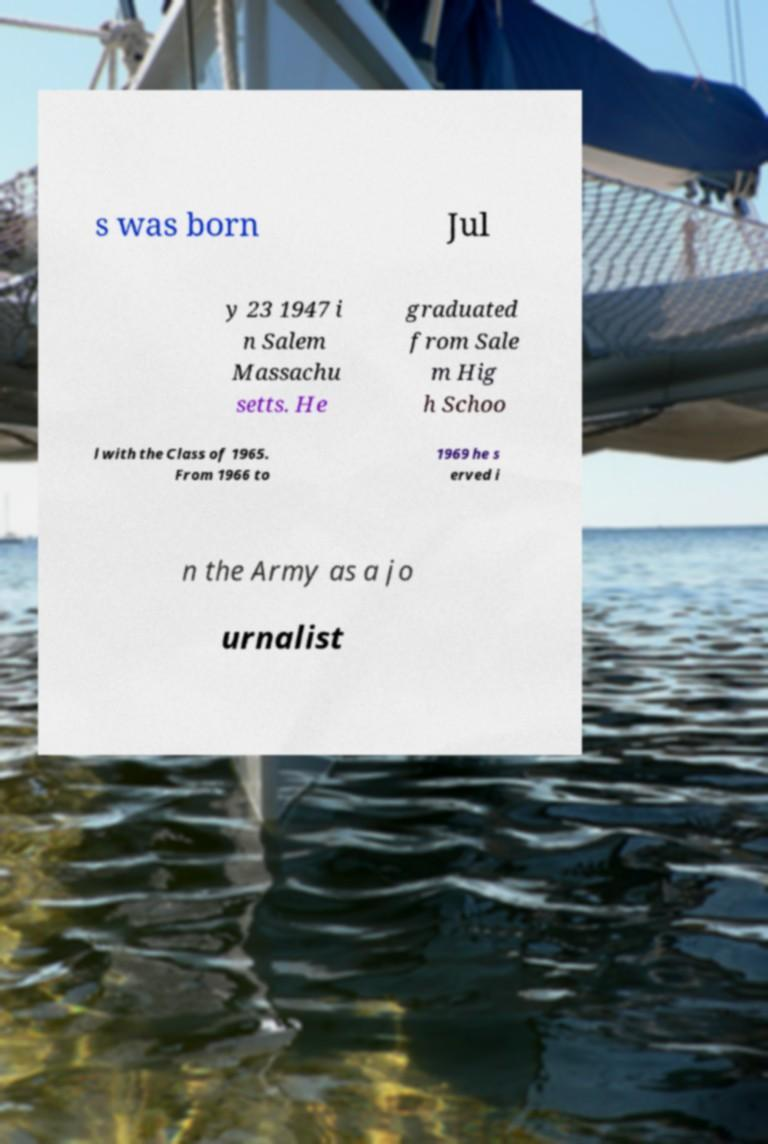Can you accurately transcribe the text from the provided image for me? s was born Jul y 23 1947 i n Salem Massachu setts. He graduated from Sale m Hig h Schoo l with the Class of 1965. From 1966 to 1969 he s erved i n the Army as a jo urnalist 